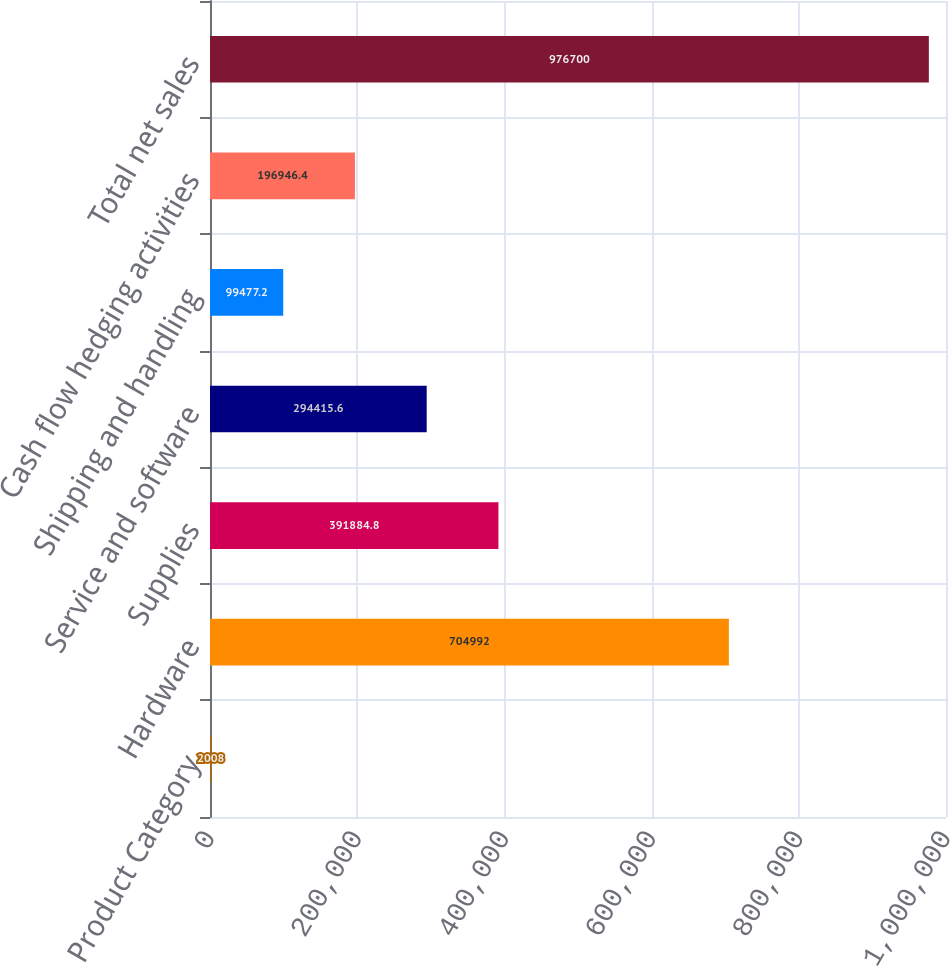Convert chart to OTSL. <chart><loc_0><loc_0><loc_500><loc_500><bar_chart><fcel>Product Category<fcel>Hardware<fcel>Supplies<fcel>Service and software<fcel>Shipping and handling<fcel>Cash flow hedging activities<fcel>Total net sales<nl><fcel>2008<fcel>704992<fcel>391885<fcel>294416<fcel>99477.2<fcel>196946<fcel>976700<nl></chart> 